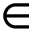<formula> <loc_0><loc_0><loc_500><loc_500>\in</formula> 